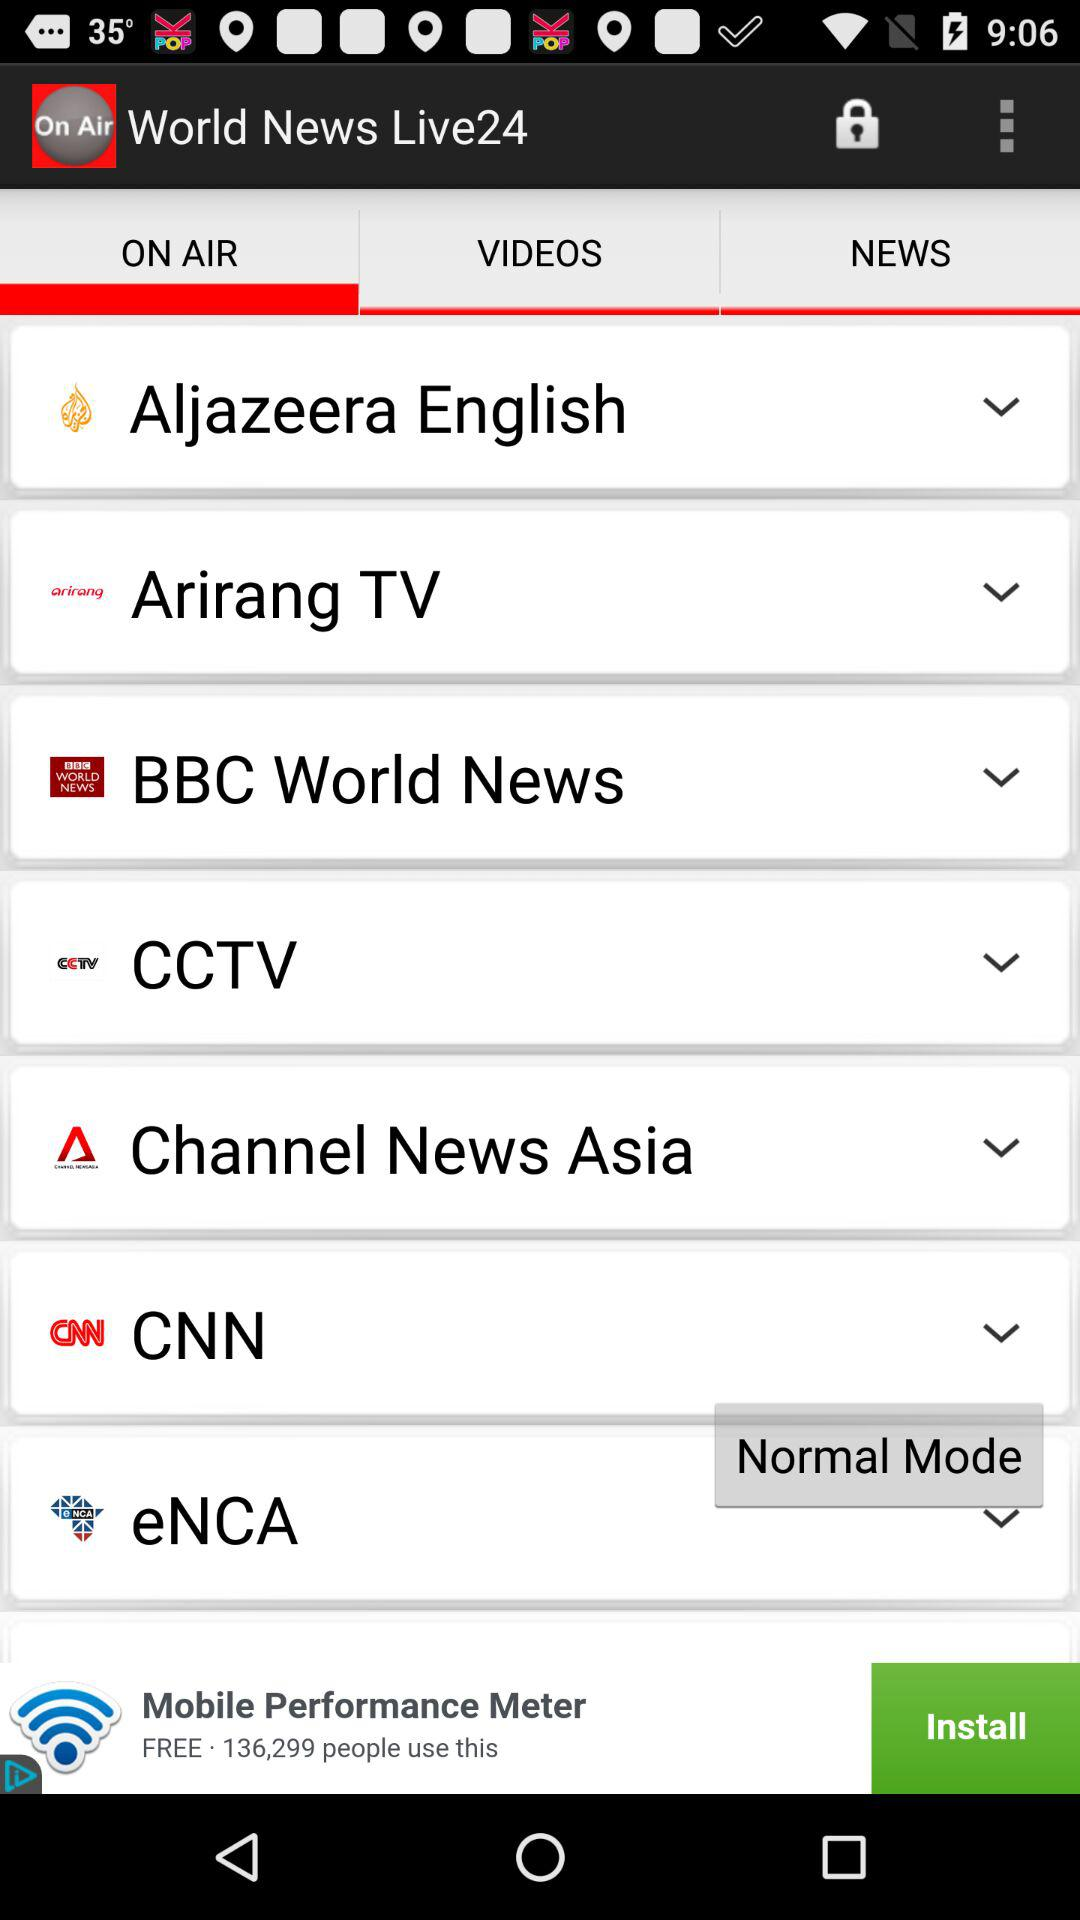Which tab am I on? You are on "ON AIR" tab. 